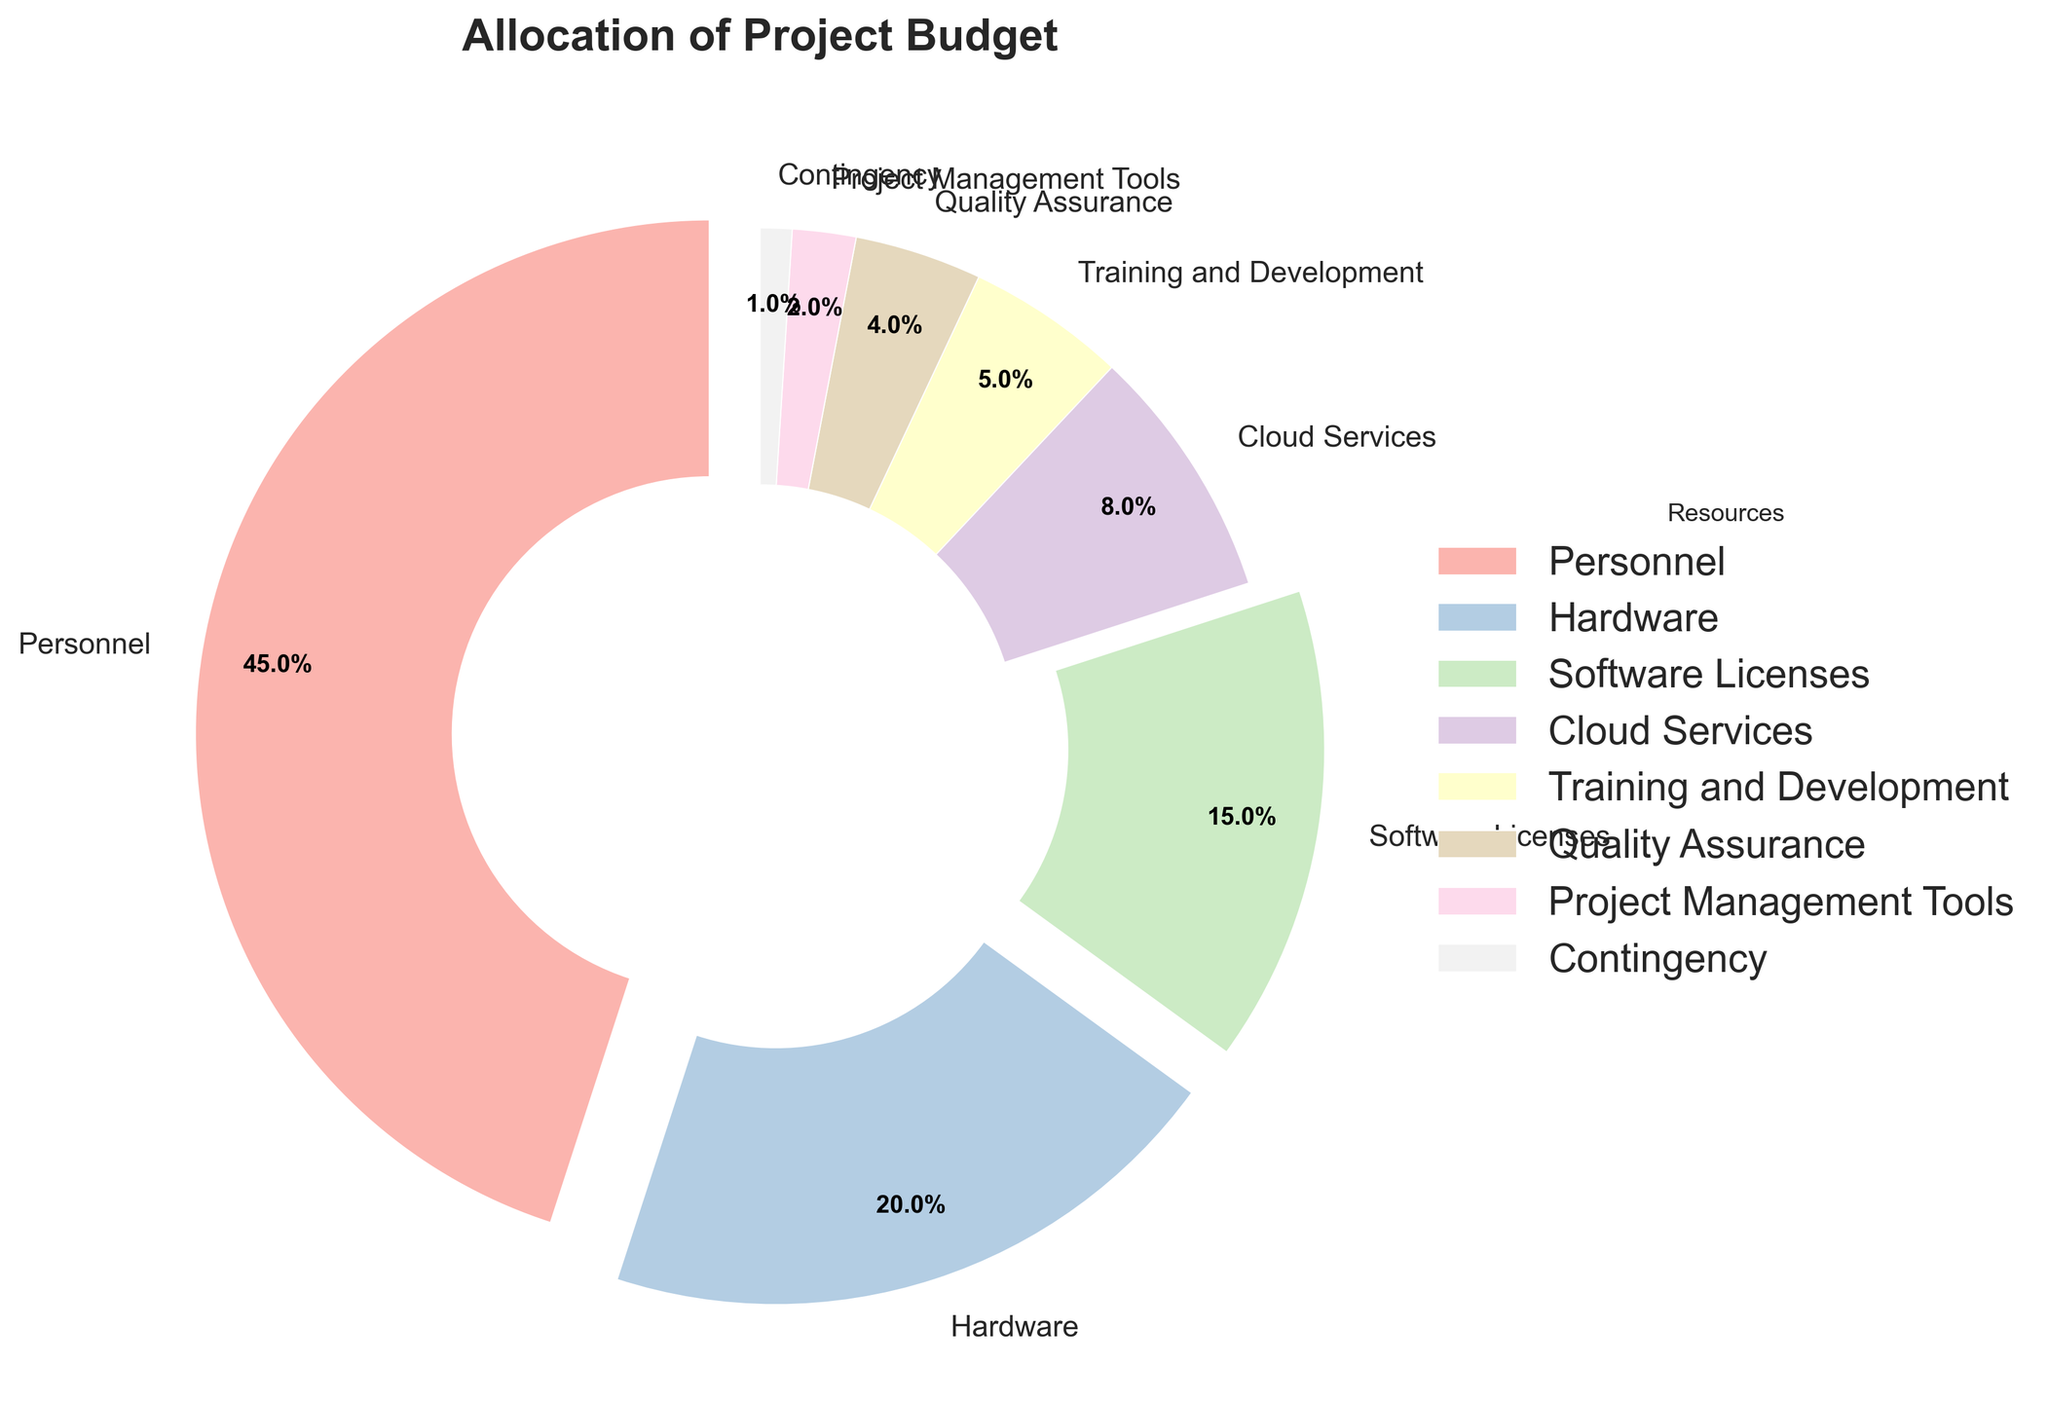What percentage of the project budget is allocated to personnel and hardware combined? The personnel budget is 45% and the hardware budget is 20%. Adding these together, 45% + 20% = 65%.
Answer: 65% Which resource has the smallest allocation and what percentage is it? Contingency has the smallest allocation with 1%. This can be seen as it has the smallest slice in the pie chart and the label indicating 1%.
Answer: Contingency, 1% How much more is allocated to personnel compared to software licenses? Personnel is allocated 45% and software licenses are allocated 15%. Thus, the difference is 45% - 15% = 30%.
Answer: 30% Which resources receive less than 5% of the budget? From the chart, the resources with allocations less than 5% are Quality Assurance (4%), Project Management Tools (2%), and Contingency (1%).
Answer: Quality Assurance, Project Management Tools, Contingency How does the percentage allocated to cloud services compare to that of training and development? The allocation for cloud services (8%) is higher than that for training and development (5%). Subtracting the training and development allocation from the cloud services allocation gives us 8% - 5% = 3%.
Answer: Cloud Services is higher by 3% What is the total budget allocation for resources that receive exactly or less than the budget allocated for software licenses? Resources receiving exactly or less than 15% of the budget are Software Licenses (15%), Cloud Services (8%), Training and Development (5%), Quality Assurance (4%), Project Management Tools (2%), and Contingency (1%). Summing these percentages: 15% + 8% + 5% + 4% + 2% + 1% = 35%.
Answer: 35% What is the largest budget allocation depicted in the pie chart? The largest budget allocation is for Personnel, which is 45%. This can be identified by the largest slice in the pie chart, as well as the label indicating 45%.
Answer: Personnel, 45% Between hardware and software licenses, which one has a higher budget allocation, and by how much? Hardware has a higher allocation (20%) than software licenses (15%). The difference is 20% - 15% = 5%.
Answer: Hardware by 5% What is the combined percentage of the budget allocated to personnel, quality assurance, and project management tools? Adding up the allocations for these resources: Personnel (45%), Quality Assurance (4%), and Project Management Tools (2%), we get 45% + 4% + 2% = 51%.
Answer: 51% What is the proportion of the budget allocated to training and development relative to cloud services? Training and Development is allocated 5% and Cloud Services 8%. The ratio is 5% / 8% = 0.625.
Answer: 0.625 